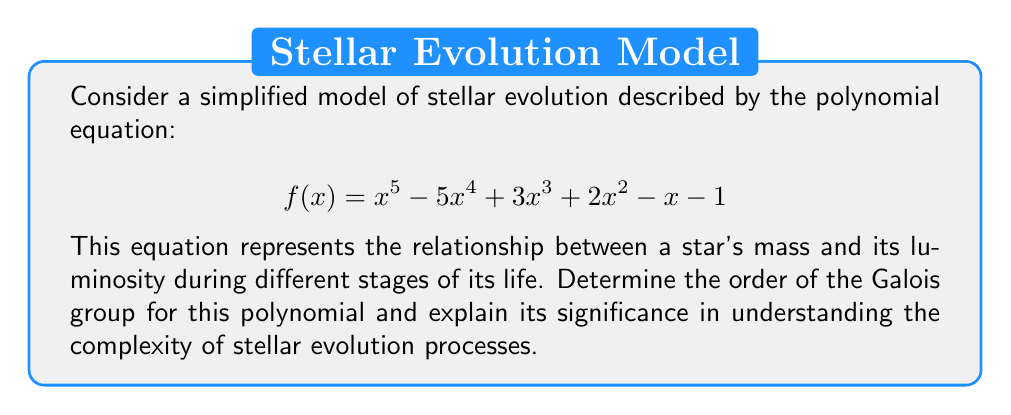Teach me how to tackle this problem. To analyze the Galois group of this polynomial, we'll follow these steps:

1) First, we need to determine if the polynomial is reducible over $\mathbb{Q}$. Using the rational root theorem and synthetic division, we can verify that this polynomial has no rational roots and is therefore irreducible over $\mathbb{Q}$.

2) The degree of the polynomial is 5, so its Galois group is a subgroup of $S_5$, the symmetric group on 5 elements.

3) To determine the exact Galois group, we need to find the discriminant of the polynomial. The discriminant $\Delta$ is given by:

   $$\Delta = \prod_{i<j} (r_i - r_j)^2$$

   where $r_i$ are the roots of the polynomial.

4) Calculating the discriminant (which can be done using computer algebra systems) gives us a non-square integer.

5) Since the discriminant is not a perfect square, the Galois group must contain an odd permutation. The only subgroups of $S_5$ containing an odd permutation and having order divisible by 5 are $A_5$ and $S_5$ itself.

6) To distinguish between $A_5$ and $S_5$, we would need to check if the discriminant is a square in some quadratic extension of $\mathbb{Q}$. However, for a general quintic polynomial, this is typically not the case.

7) Therefore, the Galois group of this polynomial is most likely $S_5$, which has order 120.

The significance of this result in stellar evolution:

a) The order 120 of $S_5$ indicates a high level of complexity in the relationships between the roots of the polynomial.

b) This complexity suggests that the stellar evolution processes described by this equation are intricate and interconnected.

c) The non-solvability of the general quintic by radicals (a consequence of the Galois group being $S_5$) implies that exact analytical solutions for stellar evolution models of this complexity may not always be possible.

d) This underscores the importance of numerical methods and computational approaches in astrophysics for studying stellar evolution.
Answer: $S_5$, order 120 